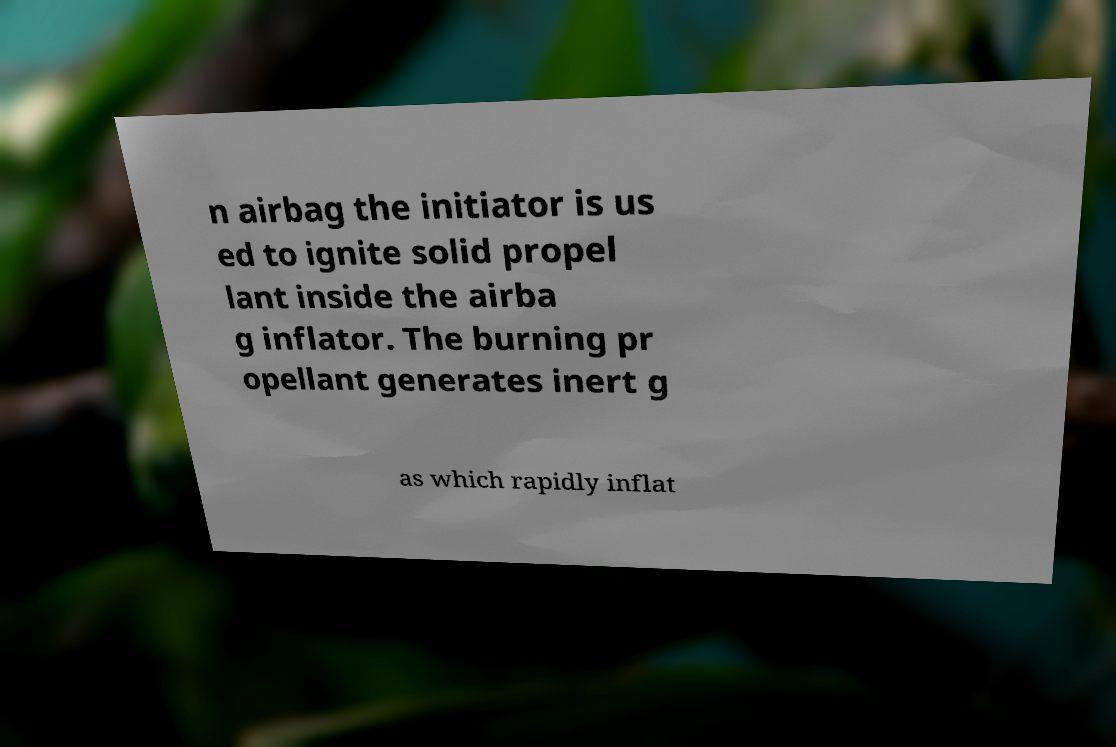Please read and relay the text visible in this image. What does it say? n airbag the initiator is us ed to ignite solid propel lant inside the airba g inflator. The burning pr opellant generates inert g as which rapidly inflat 